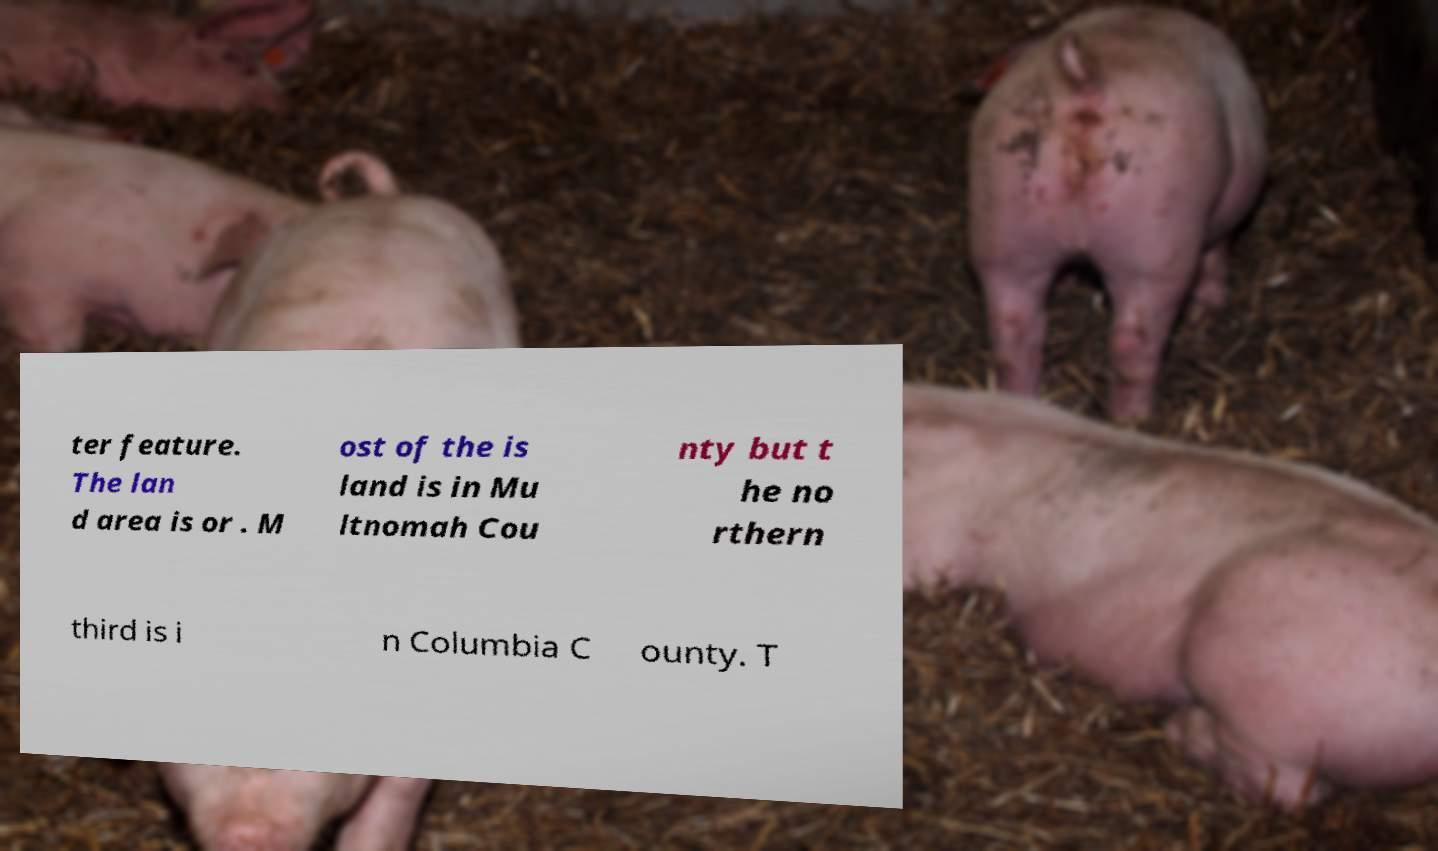What messages or text are displayed in this image? I need them in a readable, typed format. ter feature. The lan d area is or . M ost of the is land is in Mu ltnomah Cou nty but t he no rthern third is i n Columbia C ounty. T 